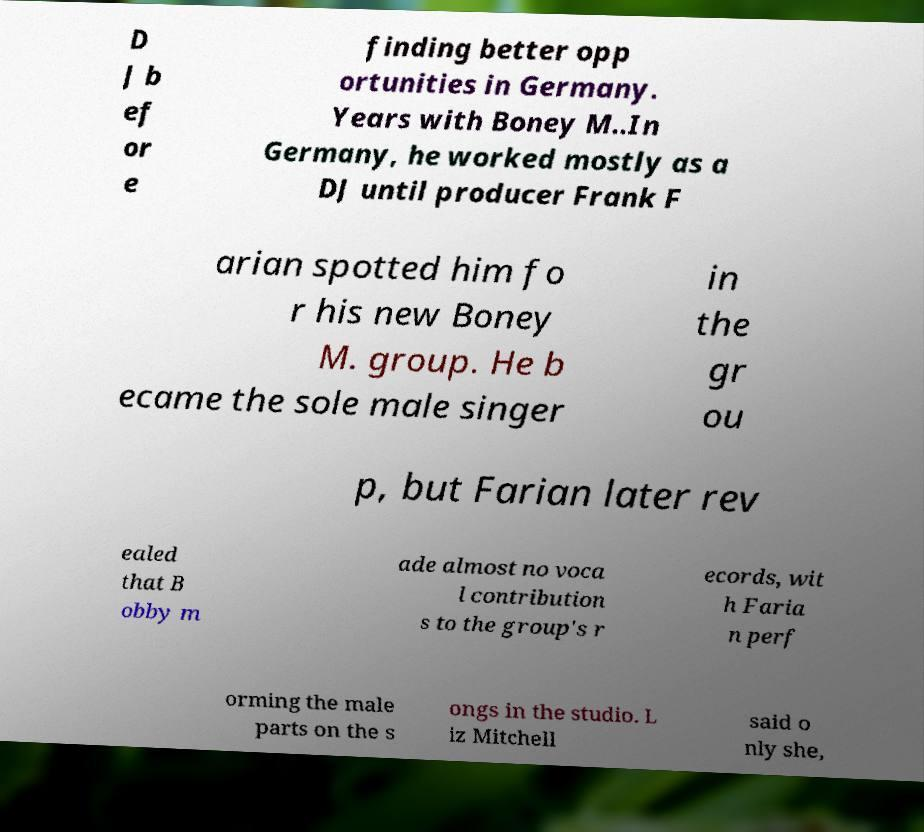Can you accurately transcribe the text from the provided image for me? D J b ef or e finding better opp ortunities in Germany. Years with Boney M..In Germany, he worked mostly as a DJ until producer Frank F arian spotted him fo r his new Boney M. group. He b ecame the sole male singer in the gr ou p, but Farian later rev ealed that B obby m ade almost no voca l contribution s to the group's r ecords, wit h Faria n perf orming the male parts on the s ongs in the studio. L iz Mitchell said o nly she, 